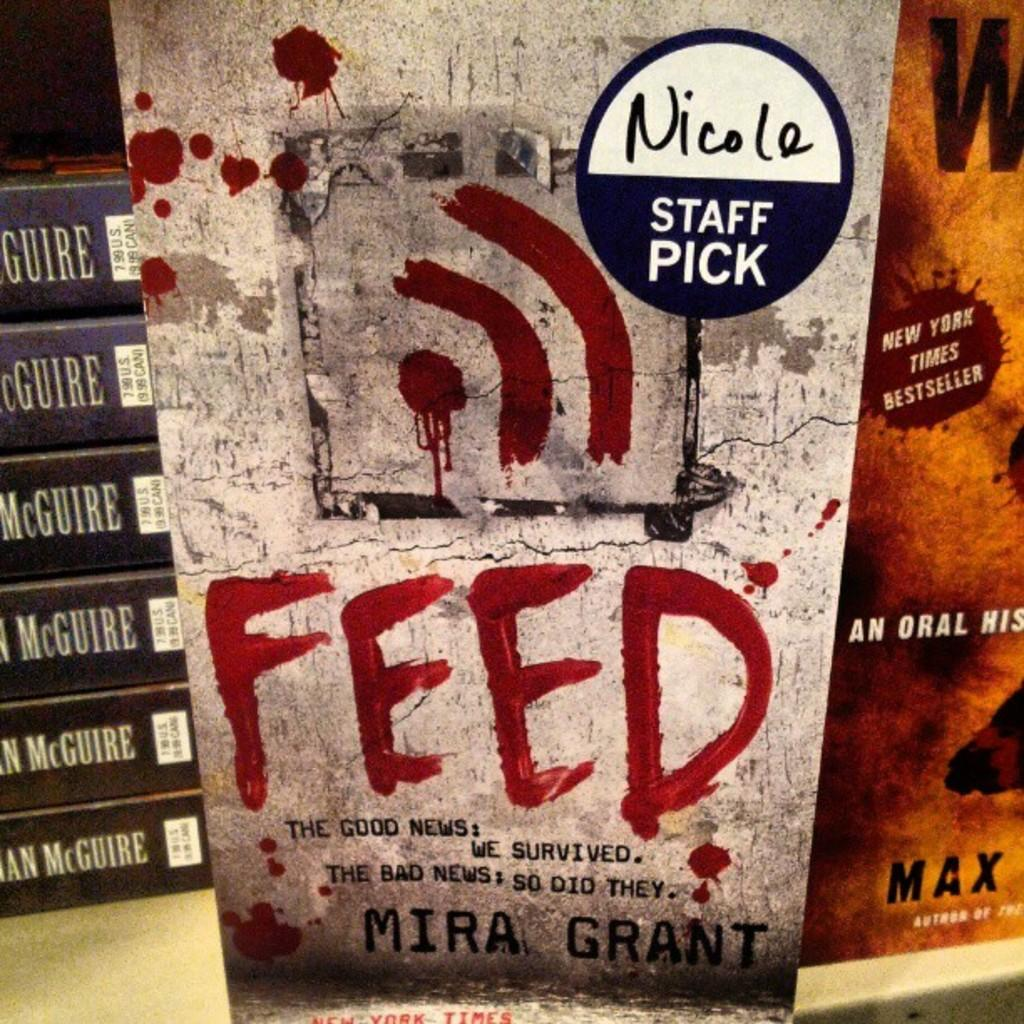<image>
Relay a brief, clear account of the picture shown. A sticker from Nicole's Staff picks is on the book Feed by Mira Grant. 